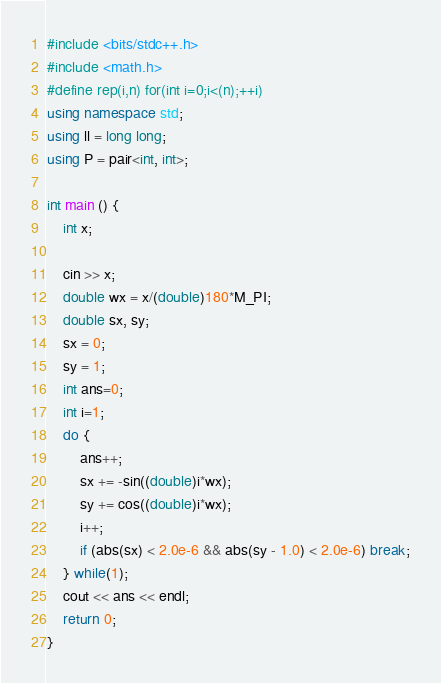Convert code to text. <code><loc_0><loc_0><loc_500><loc_500><_C++_>#include <bits/stdc++.h>
#include <math.h>
#define rep(i,n) for(int i=0;i<(n);++i)
using namespace std;
using ll = long long;
using P = pair<int, int>;

int main () {
	int x;

	cin >> x;
	double wx = x/(double)180*M_PI;
	double sx, sy;
	sx = 0;
	sy = 1;
	int ans=0;
	int i=1;
	do {
		ans++;
		sx += -sin((double)i*wx);
		sy += cos((double)i*wx);
		i++;
		if (abs(sx) < 2.0e-6 && abs(sy - 1.0) < 2.0e-6) break;
	} while(1);
	cout << ans << endl;
	return 0;
}
</code> 